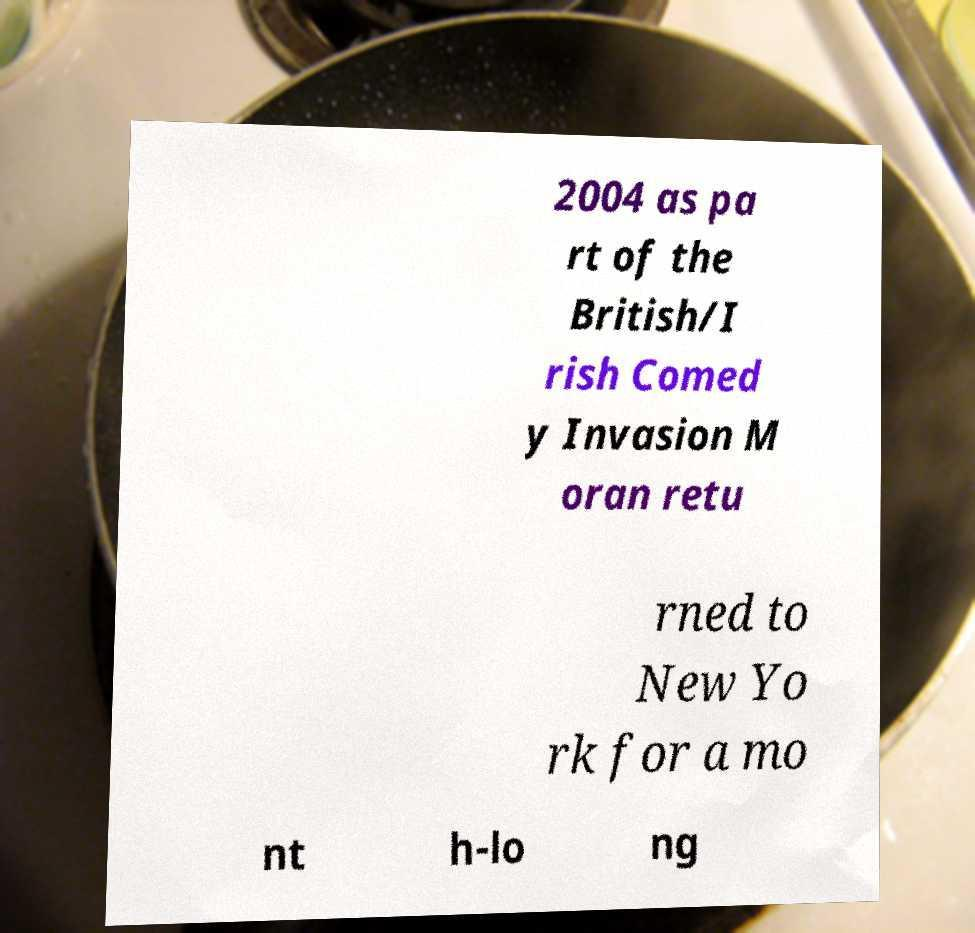Please read and relay the text visible in this image. What does it say? 2004 as pa rt of the British/I rish Comed y Invasion M oran retu rned to New Yo rk for a mo nt h-lo ng 